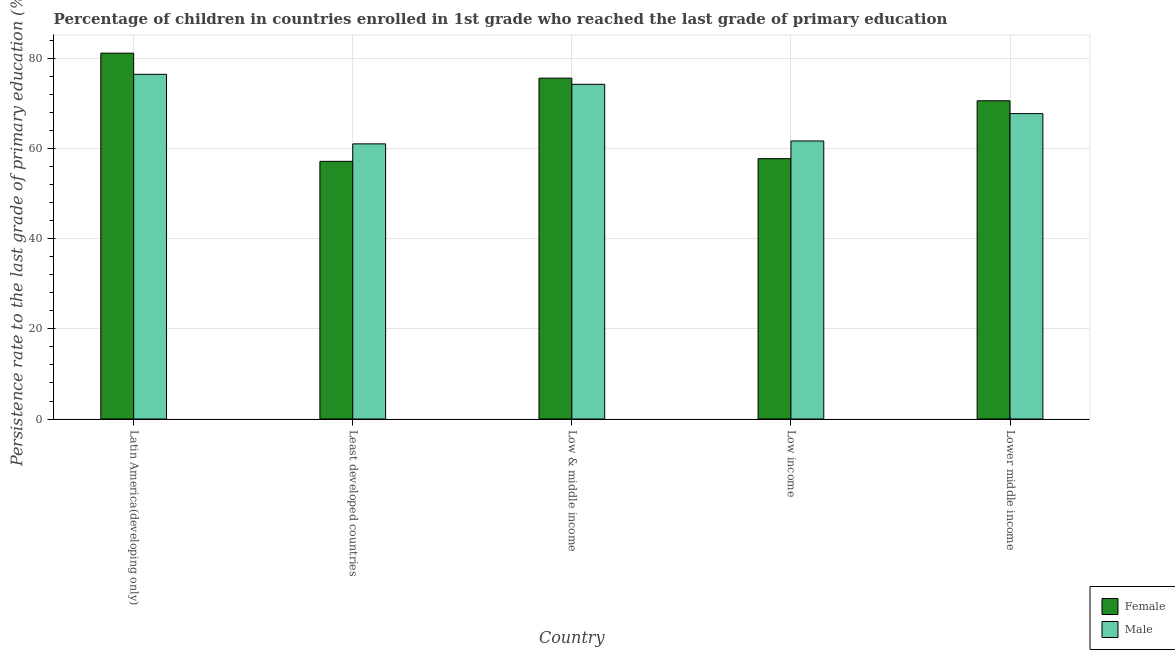How many groups of bars are there?
Your answer should be compact. 5. Are the number of bars per tick equal to the number of legend labels?
Your answer should be compact. Yes. Are the number of bars on each tick of the X-axis equal?
Your answer should be very brief. Yes. How many bars are there on the 1st tick from the left?
Offer a very short reply. 2. How many bars are there on the 2nd tick from the right?
Your answer should be very brief. 2. What is the persistence rate of male students in Least developed countries?
Provide a short and direct response. 61.1. Across all countries, what is the maximum persistence rate of male students?
Provide a succinct answer. 76.54. Across all countries, what is the minimum persistence rate of female students?
Ensure brevity in your answer.  57.22. In which country was the persistence rate of female students maximum?
Your response must be concise. Latin America(developing only). In which country was the persistence rate of male students minimum?
Your answer should be compact. Least developed countries. What is the total persistence rate of female students in the graph?
Provide a short and direct response. 342.62. What is the difference between the persistence rate of female students in Least developed countries and that in Lower middle income?
Keep it short and to the point. -13.44. What is the difference between the persistence rate of male students in Latin America(developing only) and the persistence rate of female students in Least developed countries?
Provide a short and direct response. 19.32. What is the average persistence rate of male students per country?
Make the answer very short. 68.3. What is the difference between the persistence rate of male students and persistence rate of female students in Least developed countries?
Offer a very short reply. 3.88. In how many countries, is the persistence rate of female students greater than 80 %?
Provide a succinct answer. 1. What is the ratio of the persistence rate of male students in Latin America(developing only) to that in Low & middle income?
Provide a short and direct response. 1.03. What is the difference between the highest and the second highest persistence rate of female students?
Make the answer very short. 5.55. What is the difference between the highest and the lowest persistence rate of female students?
Ensure brevity in your answer.  24.02. In how many countries, is the persistence rate of male students greater than the average persistence rate of male students taken over all countries?
Give a very brief answer. 2. Is the sum of the persistence rate of female students in Low & middle income and Lower middle income greater than the maximum persistence rate of male students across all countries?
Offer a very short reply. Yes. How many bars are there?
Keep it short and to the point. 10. Are all the bars in the graph horizontal?
Your answer should be very brief. No. How many countries are there in the graph?
Ensure brevity in your answer.  5. What is the difference between two consecutive major ticks on the Y-axis?
Your response must be concise. 20. Where does the legend appear in the graph?
Ensure brevity in your answer.  Bottom right. What is the title of the graph?
Your response must be concise. Percentage of children in countries enrolled in 1st grade who reached the last grade of primary education. Does "Fertility rate" appear as one of the legend labels in the graph?
Ensure brevity in your answer.  No. What is the label or title of the Y-axis?
Your response must be concise. Persistence rate to the last grade of primary education (%). What is the Persistence rate to the last grade of primary education (%) in Female in Latin America(developing only)?
Ensure brevity in your answer.  81.24. What is the Persistence rate to the last grade of primary education (%) in Male in Latin America(developing only)?
Give a very brief answer. 76.54. What is the Persistence rate to the last grade of primary education (%) in Female in Least developed countries?
Keep it short and to the point. 57.22. What is the Persistence rate to the last grade of primary education (%) in Male in Least developed countries?
Keep it short and to the point. 61.1. What is the Persistence rate to the last grade of primary education (%) of Female in Low & middle income?
Make the answer very short. 75.69. What is the Persistence rate to the last grade of primary education (%) in Male in Low & middle income?
Provide a short and direct response. 74.32. What is the Persistence rate to the last grade of primary education (%) of Female in Low income?
Offer a very short reply. 57.81. What is the Persistence rate to the last grade of primary education (%) in Male in Low income?
Keep it short and to the point. 61.74. What is the Persistence rate to the last grade of primary education (%) in Female in Lower middle income?
Provide a succinct answer. 70.66. What is the Persistence rate to the last grade of primary education (%) in Male in Lower middle income?
Offer a terse response. 67.82. Across all countries, what is the maximum Persistence rate to the last grade of primary education (%) in Female?
Ensure brevity in your answer.  81.24. Across all countries, what is the maximum Persistence rate to the last grade of primary education (%) of Male?
Offer a terse response. 76.54. Across all countries, what is the minimum Persistence rate to the last grade of primary education (%) of Female?
Your answer should be very brief. 57.22. Across all countries, what is the minimum Persistence rate to the last grade of primary education (%) of Male?
Give a very brief answer. 61.1. What is the total Persistence rate to the last grade of primary education (%) in Female in the graph?
Offer a very short reply. 342.62. What is the total Persistence rate to the last grade of primary education (%) of Male in the graph?
Keep it short and to the point. 341.52. What is the difference between the Persistence rate to the last grade of primary education (%) of Female in Latin America(developing only) and that in Least developed countries?
Give a very brief answer. 24.02. What is the difference between the Persistence rate to the last grade of primary education (%) in Male in Latin America(developing only) and that in Least developed countries?
Make the answer very short. 15.44. What is the difference between the Persistence rate to the last grade of primary education (%) of Female in Latin America(developing only) and that in Low & middle income?
Your answer should be compact. 5.55. What is the difference between the Persistence rate to the last grade of primary education (%) in Male in Latin America(developing only) and that in Low & middle income?
Your answer should be very brief. 2.22. What is the difference between the Persistence rate to the last grade of primary education (%) in Female in Latin America(developing only) and that in Low income?
Offer a terse response. 23.43. What is the difference between the Persistence rate to the last grade of primary education (%) of Male in Latin America(developing only) and that in Low income?
Offer a terse response. 14.8. What is the difference between the Persistence rate to the last grade of primary education (%) in Female in Latin America(developing only) and that in Lower middle income?
Your answer should be very brief. 10.57. What is the difference between the Persistence rate to the last grade of primary education (%) of Male in Latin America(developing only) and that in Lower middle income?
Offer a terse response. 8.72. What is the difference between the Persistence rate to the last grade of primary education (%) in Female in Least developed countries and that in Low & middle income?
Make the answer very short. -18.47. What is the difference between the Persistence rate to the last grade of primary education (%) in Male in Least developed countries and that in Low & middle income?
Ensure brevity in your answer.  -13.22. What is the difference between the Persistence rate to the last grade of primary education (%) in Female in Least developed countries and that in Low income?
Keep it short and to the point. -0.59. What is the difference between the Persistence rate to the last grade of primary education (%) of Male in Least developed countries and that in Low income?
Offer a terse response. -0.64. What is the difference between the Persistence rate to the last grade of primary education (%) of Female in Least developed countries and that in Lower middle income?
Offer a terse response. -13.44. What is the difference between the Persistence rate to the last grade of primary education (%) in Male in Least developed countries and that in Lower middle income?
Provide a short and direct response. -6.72. What is the difference between the Persistence rate to the last grade of primary education (%) of Female in Low & middle income and that in Low income?
Offer a very short reply. 17.87. What is the difference between the Persistence rate to the last grade of primary education (%) of Male in Low & middle income and that in Low income?
Make the answer very short. 12.58. What is the difference between the Persistence rate to the last grade of primary education (%) of Female in Low & middle income and that in Lower middle income?
Your answer should be compact. 5.02. What is the difference between the Persistence rate to the last grade of primary education (%) in Male in Low & middle income and that in Lower middle income?
Offer a terse response. 6.51. What is the difference between the Persistence rate to the last grade of primary education (%) in Female in Low income and that in Lower middle income?
Ensure brevity in your answer.  -12.85. What is the difference between the Persistence rate to the last grade of primary education (%) of Male in Low income and that in Lower middle income?
Provide a short and direct response. -6.07. What is the difference between the Persistence rate to the last grade of primary education (%) in Female in Latin America(developing only) and the Persistence rate to the last grade of primary education (%) in Male in Least developed countries?
Ensure brevity in your answer.  20.14. What is the difference between the Persistence rate to the last grade of primary education (%) in Female in Latin America(developing only) and the Persistence rate to the last grade of primary education (%) in Male in Low & middle income?
Provide a succinct answer. 6.91. What is the difference between the Persistence rate to the last grade of primary education (%) of Female in Latin America(developing only) and the Persistence rate to the last grade of primary education (%) of Male in Low income?
Ensure brevity in your answer.  19.49. What is the difference between the Persistence rate to the last grade of primary education (%) in Female in Latin America(developing only) and the Persistence rate to the last grade of primary education (%) in Male in Lower middle income?
Offer a very short reply. 13.42. What is the difference between the Persistence rate to the last grade of primary education (%) in Female in Least developed countries and the Persistence rate to the last grade of primary education (%) in Male in Low & middle income?
Give a very brief answer. -17.1. What is the difference between the Persistence rate to the last grade of primary education (%) of Female in Least developed countries and the Persistence rate to the last grade of primary education (%) of Male in Low income?
Your response must be concise. -4.52. What is the difference between the Persistence rate to the last grade of primary education (%) in Female in Least developed countries and the Persistence rate to the last grade of primary education (%) in Male in Lower middle income?
Your answer should be compact. -10.6. What is the difference between the Persistence rate to the last grade of primary education (%) in Female in Low & middle income and the Persistence rate to the last grade of primary education (%) in Male in Low income?
Provide a short and direct response. 13.94. What is the difference between the Persistence rate to the last grade of primary education (%) of Female in Low & middle income and the Persistence rate to the last grade of primary education (%) of Male in Lower middle income?
Provide a short and direct response. 7.87. What is the difference between the Persistence rate to the last grade of primary education (%) of Female in Low income and the Persistence rate to the last grade of primary education (%) of Male in Lower middle income?
Offer a terse response. -10. What is the average Persistence rate to the last grade of primary education (%) in Female per country?
Ensure brevity in your answer.  68.52. What is the average Persistence rate to the last grade of primary education (%) in Male per country?
Offer a terse response. 68.3. What is the difference between the Persistence rate to the last grade of primary education (%) in Female and Persistence rate to the last grade of primary education (%) in Male in Latin America(developing only)?
Provide a short and direct response. 4.7. What is the difference between the Persistence rate to the last grade of primary education (%) in Female and Persistence rate to the last grade of primary education (%) in Male in Least developed countries?
Keep it short and to the point. -3.88. What is the difference between the Persistence rate to the last grade of primary education (%) in Female and Persistence rate to the last grade of primary education (%) in Male in Low & middle income?
Your response must be concise. 1.36. What is the difference between the Persistence rate to the last grade of primary education (%) in Female and Persistence rate to the last grade of primary education (%) in Male in Low income?
Provide a succinct answer. -3.93. What is the difference between the Persistence rate to the last grade of primary education (%) of Female and Persistence rate to the last grade of primary education (%) of Male in Lower middle income?
Offer a very short reply. 2.85. What is the ratio of the Persistence rate to the last grade of primary education (%) in Female in Latin America(developing only) to that in Least developed countries?
Give a very brief answer. 1.42. What is the ratio of the Persistence rate to the last grade of primary education (%) of Male in Latin America(developing only) to that in Least developed countries?
Keep it short and to the point. 1.25. What is the ratio of the Persistence rate to the last grade of primary education (%) in Female in Latin America(developing only) to that in Low & middle income?
Your answer should be very brief. 1.07. What is the ratio of the Persistence rate to the last grade of primary education (%) of Male in Latin America(developing only) to that in Low & middle income?
Your answer should be compact. 1.03. What is the ratio of the Persistence rate to the last grade of primary education (%) in Female in Latin America(developing only) to that in Low income?
Keep it short and to the point. 1.41. What is the ratio of the Persistence rate to the last grade of primary education (%) in Male in Latin America(developing only) to that in Low income?
Make the answer very short. 1.24. What is the ratio of the Persistence rate to the last grade of primary education (%) in Female in Latin America(developing only) to that in Lower middle income?
Provide a short and direct response. 1.15. What is the ratio of the Persistence rate to the last grade of primary education (%) in Male in Latin America(developing only) to that in Lower middle income?
Ensure brevity in your answer.  1.13. What is the ratio of the Persistence rate to the last grade of primary education (%) in Female in Least developed countries to that in Low & middle income?
Your response must be concise. 0.76. What is the ratio of the Persistence rate to the last grade of primary education (%) in Male in Least developed countries to that in Low & middle income?
Keep it short and to the point. 0.82. What is the ratio of the Persistence rate to the last grade of primary education (%) of Female in Least developed countries to that in Low income?
Offer a very short reply. 0.99. What is the ratio of the Persistence rate to the last grade of primary education (%) in Female in Least developed countries to that in Lower middle income?
Offer a terse response. 0.81. What is the ratio of the Persistence rate to the last grade of primary education (%) of Male in Least developed countries to that in Lower middle income?
Your answer should be very brief. 0.9. What is the ratio of the Persistence rate to the last grade of primary education (%) in Female in Low & middle income to that in Low income?
Offer a terse response. 1.31. What is the ratio of the Persistence rate to the last grade of primary education (%) in Male in Low & middle income to that in Low income?
Make the answer very short. 1.2. What is the ratio of the Persistence rate to the last grade of primary education (%) of Female in Low & middle income to that in Lower middle income?
Your answer should be compact. 1.07. What is the ratio of the Persistence rate to the last grade of primary education (%) in Male in Low & middle income to that in Lower middle income?
Give a very brief answer. 1.1. What is the ratio of the Persistence rate to the last grade of primary education (%) of Female in Low income to that in Lower middle income?
Offer a terse response. 0.82. What is the ratio of the Persistence rate to the last grade of primary education (%) in Male in Low income to that in Lower middle income?
Your answer should be very brief. 0.91. What is the difference between the highest and the second highest Persistence rate to the last grade of primary education (%) in Female?
Provide a succinct answer. 5.55. What is the difference between the highest and the second highest Persistence rate to the last grade of primary education (%) of Male?
Give a very brief answer. 2.22. What is the difference between the highest and the lowest Persistence rate to the last grade of primary education (%) in Female?
Provide a short and direct response. 24.02. What is the difference between the highest and the lowest Persistence rate to the last grade of primary education (%) of Male?
Your response must be concise. 15.44. 